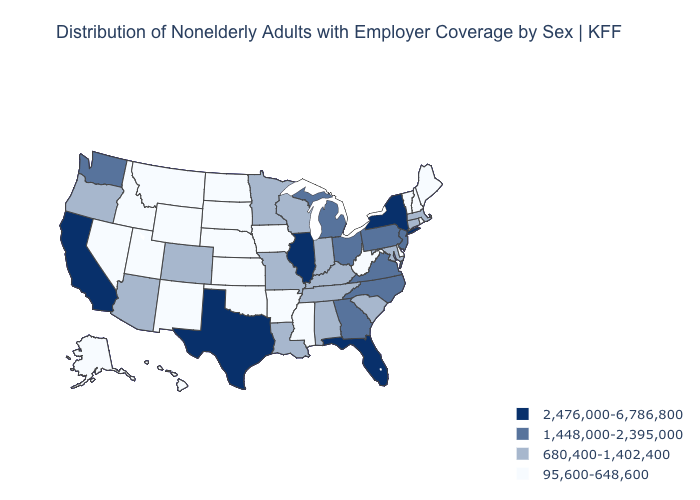Name the states that have a value in the range 1,448,000-2,395,000?
Concise answer only. Georgia, Michigan, New Jersey, North Carolina, Ohio, Pennsylvania, Virginia, Washington. Is the legend a continuous bar?
Give a very brief answer. No. Name the states that have a value in the range 2,476,000-6,786,800?
Be succinct. California, Florida, Illinois, New York, Texas. What is the highest value in the MidWest ?
Be succinct. 2,476,000-6,786,800. What is the highest value in states that border North Carolina?
Short answer required. 1,448,000-2,395,000. Which states hav the highest value in the MidWest?
Answer briefly. Illinois. Does Arkansas have the lowest value in the USA?
Answer briefly. Yes. What is the value of Arizona?
Concise answer only. 680,400-1,402,400. Among the states that border Minnesota , does North Dakota have the highest value?
Give a very brief answer. No. What is the value of Maine?
Answer briefly. 95,600-648,600. Does the map have missing data?
Write a very short answer. No. What is the value of Vermont?
Concise answer only. 95,600-648,600. What is the value of South Dakota?
Answer briefly. 95,600-648,600. What is the highest value in the Northeast ?
Write a very short answer. 2,476,000-6,786,800. What is the value of Florida?
Keep it brief. 2,476,000-6,786,800. 